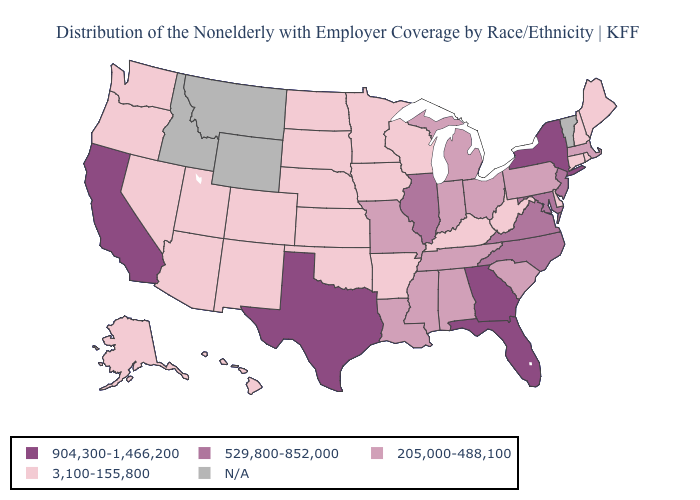Which states have the lowest value in the Northeast?
Concise answer only. Connecticut, Maine, New Hampshire, Rhode Island. Name the states that have a value in the range 205,000-488,100?
Keep it brief. Alabama, Indiana, Louisiana, Massachusetts, Michigan, Mississippi, Missouri, Ohio, Pennsylvania, South Carolina, Tennessee. Among the states that border Arizona , does New Mexico have the highest value?
Keep it brief. No. Does the map have missing data?
Keep it brief. Yes. Among the states that border South Carolina , which have the lowest value?
Keep it brief. North Carolina. Name the states that have a value in the range 529,800-852,000?
Keep it brief. Illinois, Maryland, New Jersey, North Carolina, Virginia. Among the states that border Minnesota , which have the highest value?
Keep it brief. Iowa, North Dakota, South Dakota, Wisconsin. Name the states that have a value in the range 904,300-1,466,200?
Keep it brief. California, Florida, Georgia, New York, Texas. What is the highest value in the Northeast ?
Give a very brief answer. 904,300-1,466,200. Among the states that border Georgia , which have the lowest value?
Write a very short answer. Alabama, South Carolina, Tennessee. Name the states that have a value in the range 529,800-852,000?
Answer briefly. Illinois, Maryland, New Jersey, North Carolina, Virginia. Which states have the lowest value in the Northeast?
Concise answer only. Connecticut, Maine, New Hampshire, Rhode Island. Among the states that border Connecticut , which have the highest value?
Answer briefly. New York. Name the states that have a value in the range 904,300-1,466,200?
Write a very short answer. California, Florida, Georgia, New York, Texas. What is the value of Colorado?
Be succinct. 3,100-155,800. 